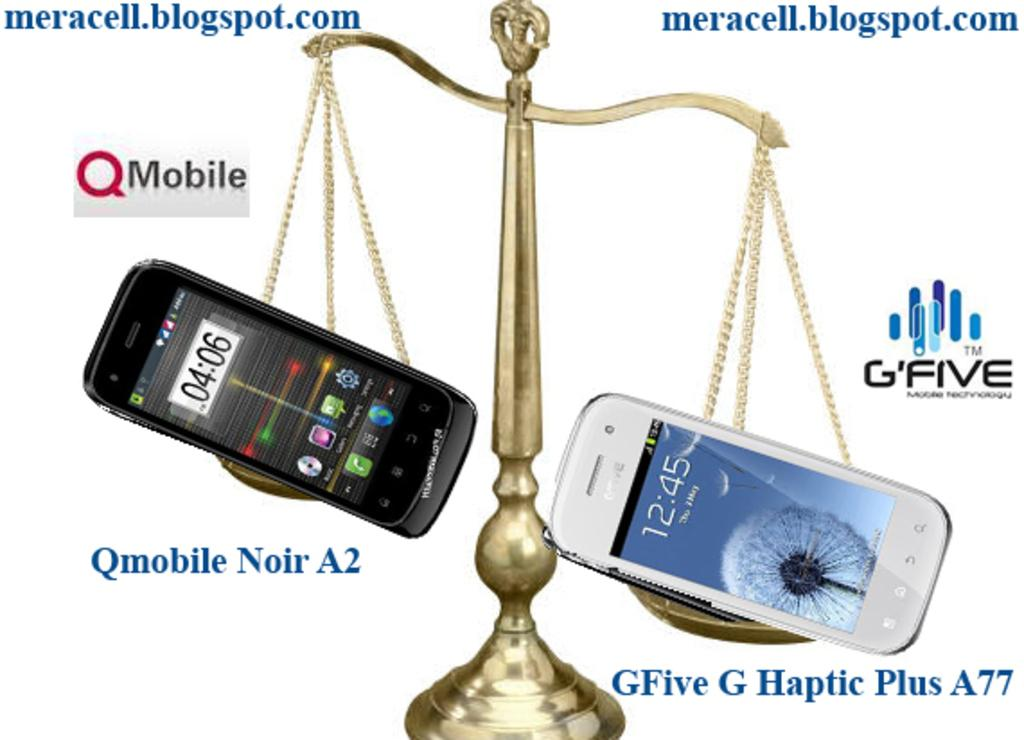<image>
Share a concise interpretation of the image provided. An advertisement has two smart phones being held up by scales as if to compare them, with the names of the phone printed underneath them. 